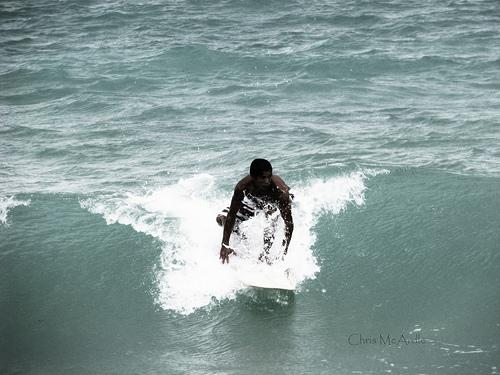Question: what is the man doing?
Choices:
A. Skiing.
B. Skating.
C. Surfing.
D. Riding a bicycle.
Answer with the letter. Answer: C Question: who is in the water?
Choices:
A. The man.
B. Three surfers.
C. A woman in bikini.
D. Two small children.
Answer with the letter. Answer: A Question: when was this taken?
Choices:
A. In the afternoon.
B. In the early evening.
C. During the day.
D. In the morning.
Answer with the letter. Answer: C Question: where is the man?
Choices:
A. Beach.
B. Ocean.
C. Forest.
D. Park.
Answer with the letter. Answer: B 